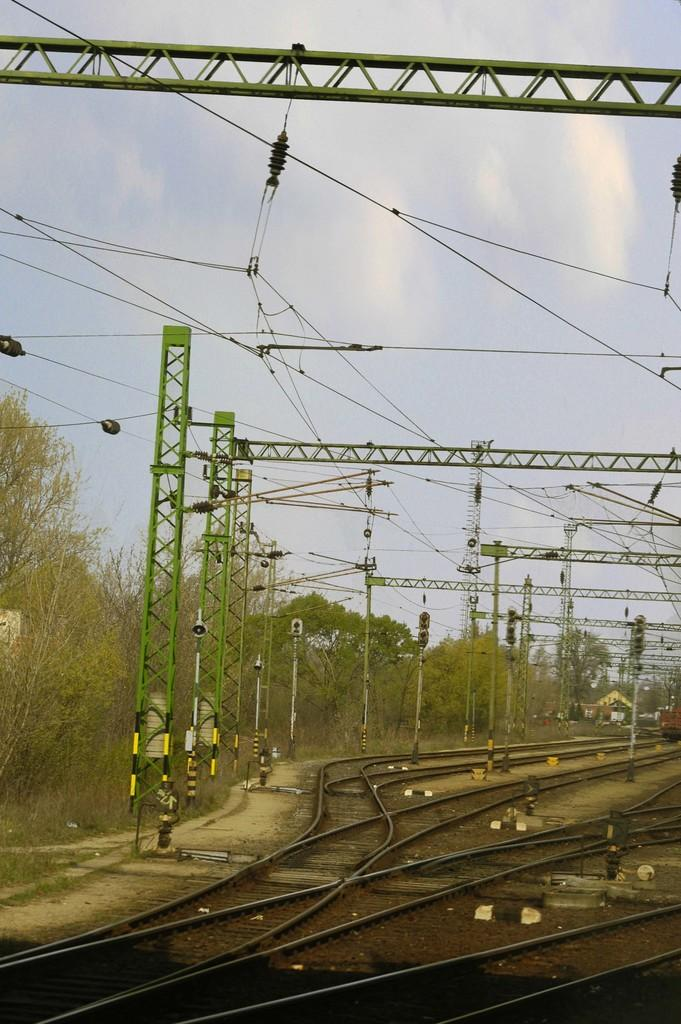What type of infrastructure is visible in the image? There are railway tracks in the image. What is attached to the current poles in the image? Wires and traffic signals are attached to the current poles in the image. What type of vegetation can be seen in the image? There are trees in the image. What is visible in the sky in the image? The sky is visible in the image, and clouds are present. What type of neck accessory is worn by the lawyer in the image? There is no lawyer or neck accessory present in the image. What type of frame surrounds the image? The provided facts do not mention a frame surrounding the image. 